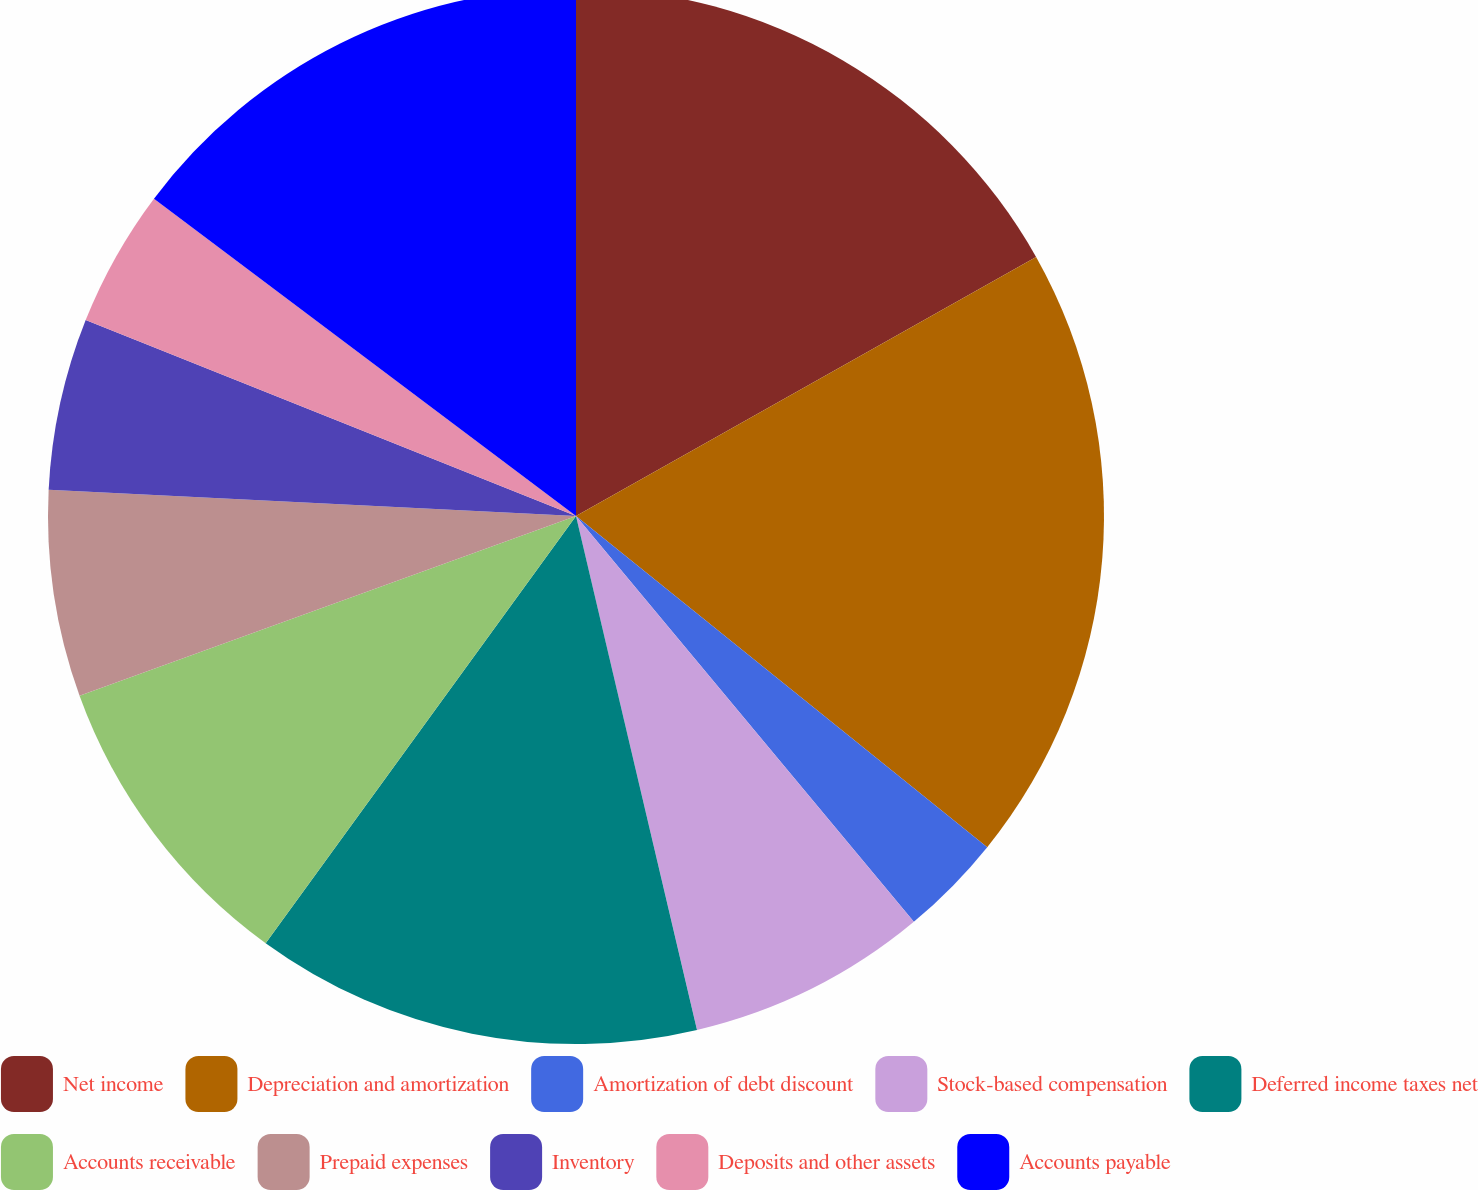Convert chart to OTSL. <chart><loc_0><loc_0><loc_500><loc_500><pie_chart><fcel>Net income<fcel>Depreciation and amortization<fcel>Amortization of debt discount<fcel>Stock-based compensation<fcel>Deferred income taxes net<fcel>Accounts receivable<fcel>Prepaid expenses<fcel>Inventory<fcel>Deposits and other assets<fcel>Accounts payable<nl><fcel>16.84%<fcel>18.95%<fcel>3.16%<fcel>7.37%<fcel>13.68%<fcel>9.47%<fcel>6.32%<fcel>5.26%<fcel>4.21%<fcel>14.74%<nl></chart> 